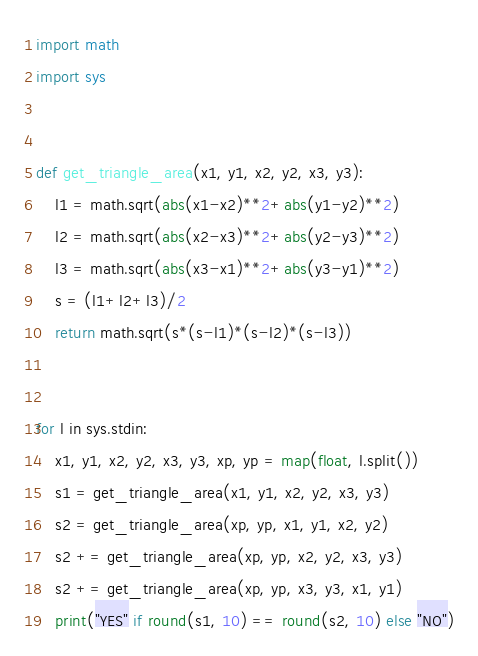Convert code to text. <code><loc_0><loc_0><loc_500><loc_500><_Python_>import math
import sys


def get_triangle_area(x1, y1, x2, y2, x3, y3):
    l1 = math.sqrt(abs(x1-x2)**2+abs(y1-y2)**2)
    l2 = math.sqrt(abs(x2-x3)**2+abs(y2-y3)**2)
    l3 = math.sqrt(abs(x3-x1)**2+abs(y3-y1)**2)
    s = (l1+l2+l3)/2
    return math.sqrt(s*(s-l1)*(s-l2)*(s-l3))


for l in sys.stdin:
    x1, y1, x2, y2, x3, y3, xp, yp = map(float, l.split())
    s1 = get_triangle_area(x1, y1, x2, y2, x3, y3)
    s2 = get_triangle_area(xp, yp, x1, y1, x2, y2)
    s2 += get_triangle_area(xp, yp, x2, y2, x3, y3)
    s2 += get_triangle_area(xp, yp, x3, y3, x1, y1)
    print("YES" if round(s1, 10) == round(s2, 10) else "NO")</code> 